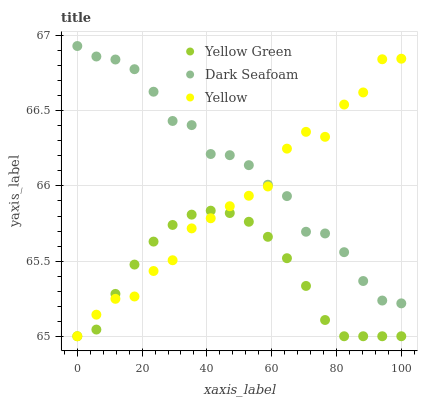Does Yellow Green have the minimum area under the curve?
Answer yes or no. Yes. Does Dark Seafoam have the maximum area under the curve?
Answer yes or no. Yes. Does Yellow have the minimum area under the curve?
Answer yes or no. No. Does Yellow have the maximum area under the curve?
Answer yes or no. No. Is Yellow Green the smoothest?
Answer yes or no. Yes. Is Yellow the roughest?
Answer yes or no. Yes. Is Yellow the smoothest?
Answer yes or no. No. Is Yellow Green the roughest?
Answer yes or no. No. Does Yellow Green have the lowest value?
Answer yes or no. Yes. Does Dark Seafoam have the highest value?
Answer yes or no. Yes. Does Yellow have the highest value?
Answer yes or no. No. Is Yellow Green less than Dark Seafoam?
Answer yes or no. Yes. Is Dark Seafoam greater than Yellow Green?
Answer yes or no. Yes. Does Yellow intersect Dark Seafoam?
Answer yes or no. Yes. Is Yellow less than Dark Seafoam?
Answer yes or no. No. Is Yellow greater than Dark Seafoam?
Answer yes or no. No. Does Yellow Green intersect Dark Seafoam?
Answer yes or no. No. 